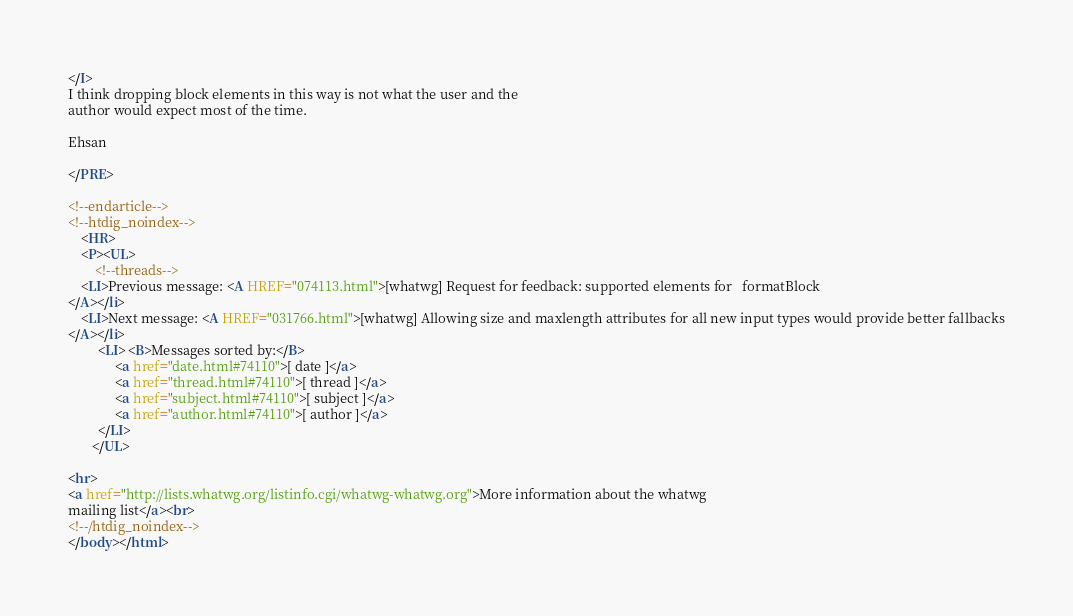Convert code to text. <code><loc_0><loc_0><loc_500><loc_500><_HTML_></I>
I think dropping block elements in this way is not what the user and the 
author would expect most of the time.

Ehsan

</PRE>

<!--endarticle-->
<!--htdig_noindex-->
    <HR>
    <P><UL>
        <!--threads-->
	<LI>Previous message: <A HREF="074113.html">[whatwg] Request for feedback: supported elements for	formatBlock
</A></li>
	<LI>Next message: <A HREF="031766.html">[whatwg] Allowing size and maxlength attributes for all new input types would provide better fallbacks
</A></li>
         <LI> <B>Messages sorted by:</B> 
              <a href="date.html#74110">[ date ]</a>
              <a href="thread.html#74110">[ thread ]</a>
              <a href="subject.html#74110">[ subject ]</a>
              <a href="author.html#74110">[ author ]</a>
         </LI>
       </UL>

<hr>
<a href="http://lists.whatwg.org/listinfo.cgi/whatwg-whatwg.org">More information about the whatwg
mailing list</a><br>
<!--/htdig_noindex-->
</body></html>
</code> 